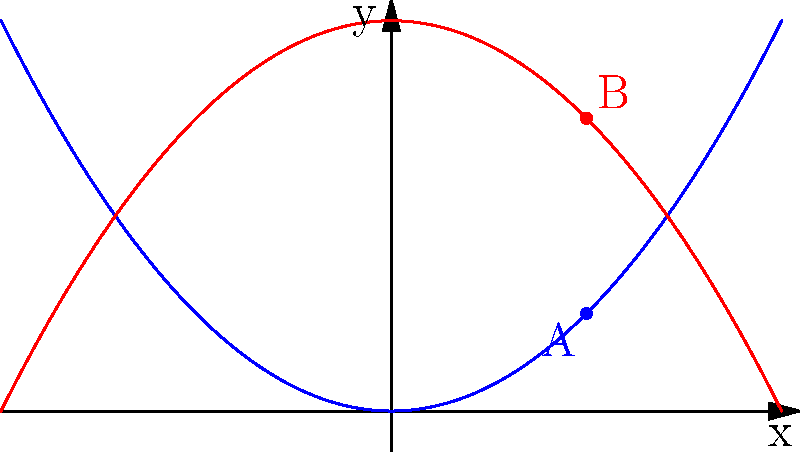In a classic Hungarian animated short, two characters are moving along parabolic paths. Character A follows the blue path described by the equation $y = 0.25x^2$, while character B follows the red path described by $y = -0.25x^2 + 4$. At $t = 2$ seconds, both characters are at $x = 2$. Calculate the distance between the two characters at this moment. Let's approach this step-by-step:

1) First, we need to find the y-coordinates of both characters at $x = 2$.

   For character A: 
   $y_A = 0.25(2)^2 = 0.25 * 4 = 1$

   For character B:
   $y_B = -0.25(2)^2 + 4 = -0.25 * 4 + 4 = 3$

2) Now we have the coordinates of both characters:
   A(2, 1) and B(2, 3)

3) To find the distance between these points, we can use the distance formula:
   
   $d = \sqrt{(x_2 - x_1)^2 + (y_2 - y_1)^2}$

4) Plugging in our values:

   $d = \sqrt{(2 - 2)^2 + (3 - 1)^2}$

5) Simplify:

   $d = \sqrt{0^2 + 2^2} = \sqrt{4} = 2$

Therefore, the distance between the two characters at $t = 2$ seconds is 2 units.
Answer: 2 units 